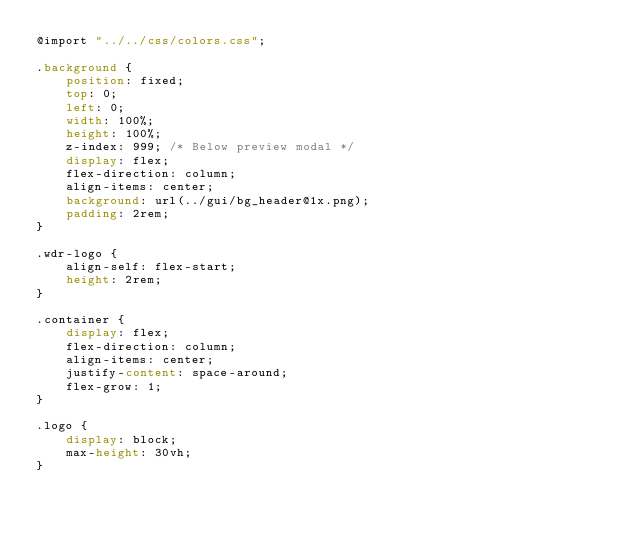Convert code to text. <code><loc_0><loc_0><loc_500><loc_500><_CSS_>@import "../../css/colors.css";

.background {
    position: fixed;
    top: 0;
    left: 0;
    width: 100%;
    height: 100%;
    z-index: 999; /* Below preview modal */
    display: flex;
    flex-direction: column;
    align-items: center;
    background: url(../gui/bg_header@1x.png);
    padding: 2rem;
}

.wdr-logo {
    align-self: flex-start;
    height: 2rem;
}

.container {
    display: flex;
    flex-direction: column;
    align-items: center;
    justify-content: space-around;
    flex-grow: 1;
}

.logo {
    display: block;
    max-height: 30vh;
}
</code> 